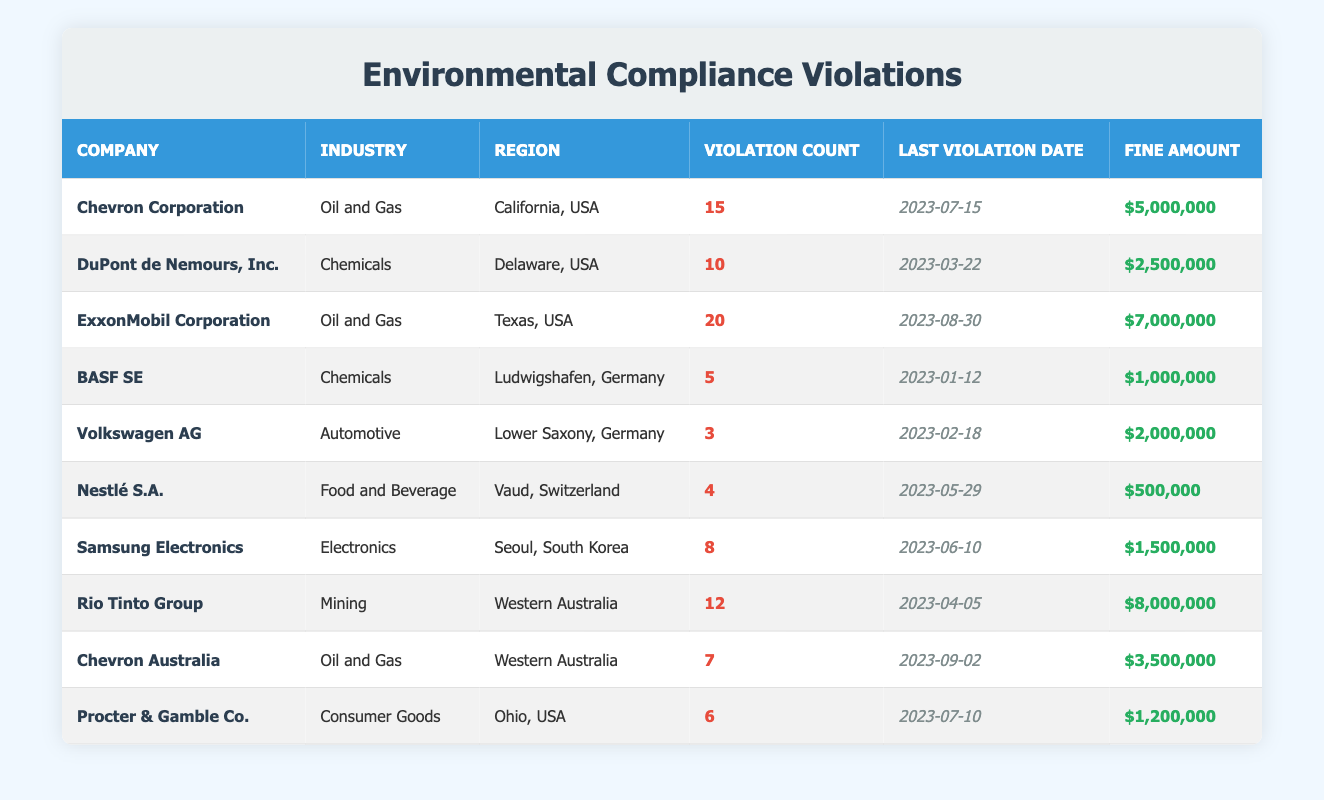What is the total number of environmental compliance violations reported in Texas, USA? There are 3 companies reporting violations in Texas. Summing their violation counts gives (20 from ExxonMobil Corporation) = 20.
Answer: 20 What is the fine amount for the company with the most recent violation? The company with the most recent violation is Chevron Australia, with a violation date of 2023-09-02, which has a fine amount of $3,500,000.
Answer: $3,500,000 How many violations were reported by DuPont de Nemours, Inc.? DuPont de Nemours, Inc. has a violation count of 10 as per the table.
Answer: 10 Which company has the highest total fine amount? We need to look at each company's fine amount. ExxonMobil Corporation has $7,000,000, followed by Rio Tinto Group with $8,000,000, which is highest.
Answer: Rio Tinto Group True or False: Samsung Electronics has more violations than Nestlé S.A. Samsung Electronics has 8 violations while Nestlé S.A. has 4 violations, so it is true that Samsung has more.
Answer: True What is the average fine amount for the companies listed in the Automotive industry? There is only one company in the Automotive industry, Volkswagen AG, which has a fine amount of $2,000,000. Since there's only one, the average is also $2,000,000.
Answer: $2,000,000 How many violations did Oil and Gas companies in Western Australia report in total? There are two companies: Chevron Australia with 7 violations and Rio Tinto Group with 12 violations. The total is 7 + 12 = 19.
Answer: 19 Which region reported the lowest number of violations in this table? Looking at the violation counts, Volkswagen AG in Lower Saxony, Germany has the lowest at 3 violations.
Answer: Lower Saxony, Germany Was the fine amount for Procter & Gamble Co. higher than that for BASF SE? Procter & Gamble Co. has a fine amount of $1,200,000 while BASF SE has $1,000,000. Since $1,200,000 is greater than $1,000,000, the statement is true.
Answer: True How many companies reported violations in California? The table shows that only one company, Chevron Corporation, reported violations in California with a count of 15.
Answer: 1 